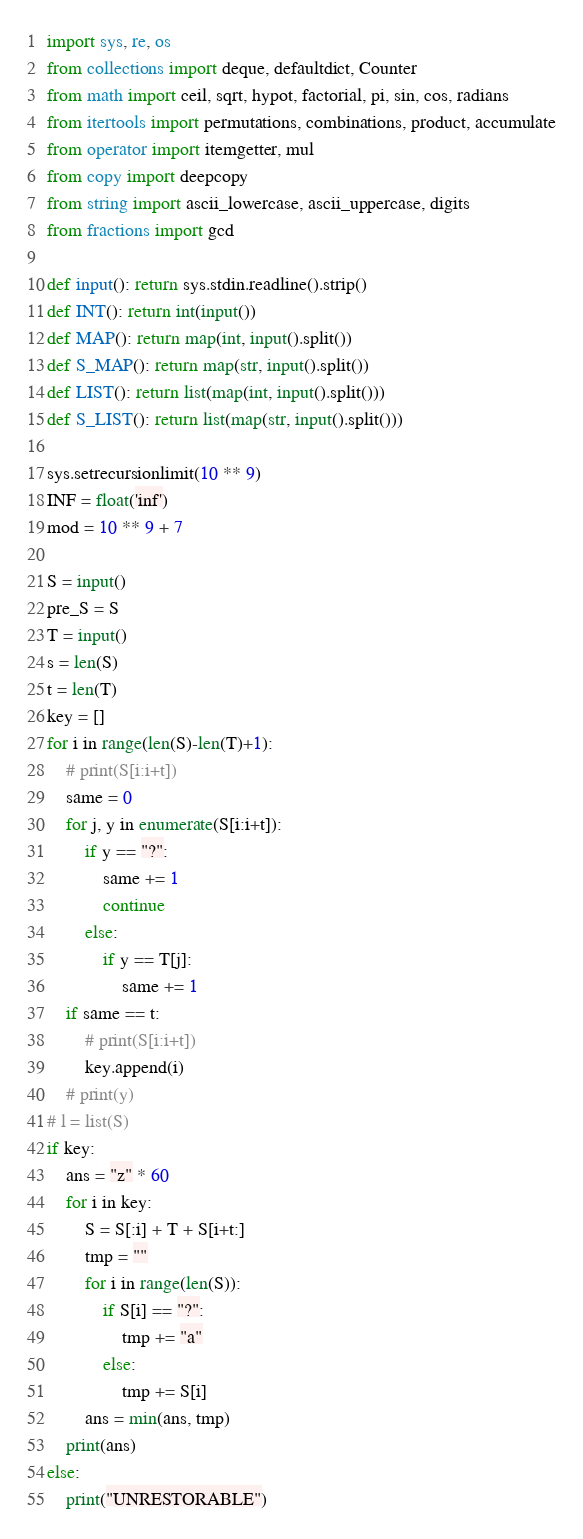<code> <loc_0><loc_0><loc_500><loc_500><_Python_>import sys, re, os
from collections import deque, defaultdict, Counter
from math import ceil, sqrt, hypot, factorial, pi, sin, cos, radians
from itertools import permutations, combinations, product, accumulate
from operator import itemgetter, mul
from copy import deepcopy
from string import ascii_lowercase, ascii_uppercase, digits
from fractions import gcd
 
def input(): return sys.stdin.readline().strip()
def INT(): return int(input())
def MAP(): return map(int, input().split())
def S_MAP(): return map(str, input().split())
def LIST(): return list(map(int, input().split()))
def S_LIST(): return list(map(str, input().split()))
 
sys.setrecursionlimit(10 ** 9)
INF = float('inf')
mod = 10 ** 9 + 7

S = input()
pre_S = S
T = input()
s = len(S)
t = len(T)
key = []
for i in range(len(S)-len(T)+1):
    # print(S[i:i+t])
    same = 0
    for j, y in enumerate(S[i:i+t]):
        if y == "?":
            same += 1
            continue
        else:
            if y == T[j]:
                same += 1
    if same == t:
        # print(S[i:i+t])
        key.append(i)
    # print(y)
# l = list(S)
if key:
    ans = "z" * 60
    for i in key:
        S = S[:i] + T + S[i+t:]
        tmp = ""
        for i in range(len(S)):
            if S[i] == "?":
                tmp += "a"
            else:
                tmp += S[i]
        ans = min(ans, tmp)
    print(ans)
else:
    print("UNRESTORABLE")

</code> 